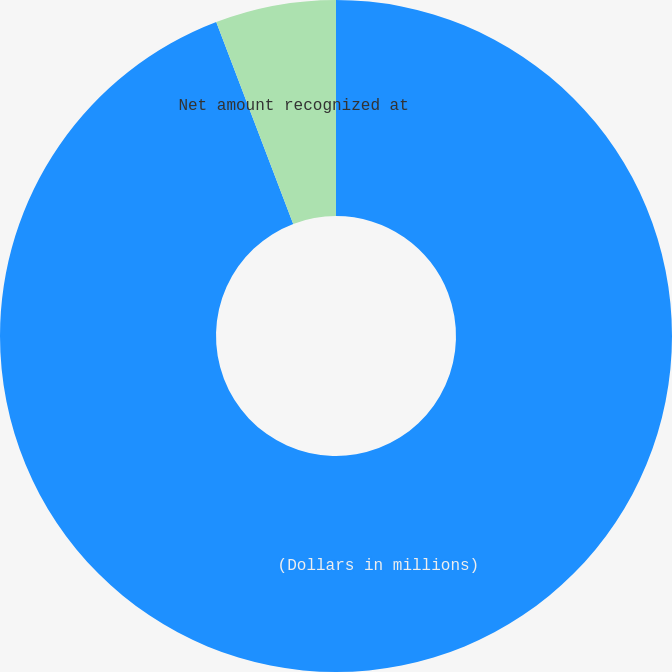Convert chart to OTSL. <chart><loc_0><loc_0><loc_500><loc_500><pie_chart><fcel>(Dollars in millions)<fcel>Net amount recognized at<nl><fcel>94.2%<fcel>5.8%<nl></chart> 